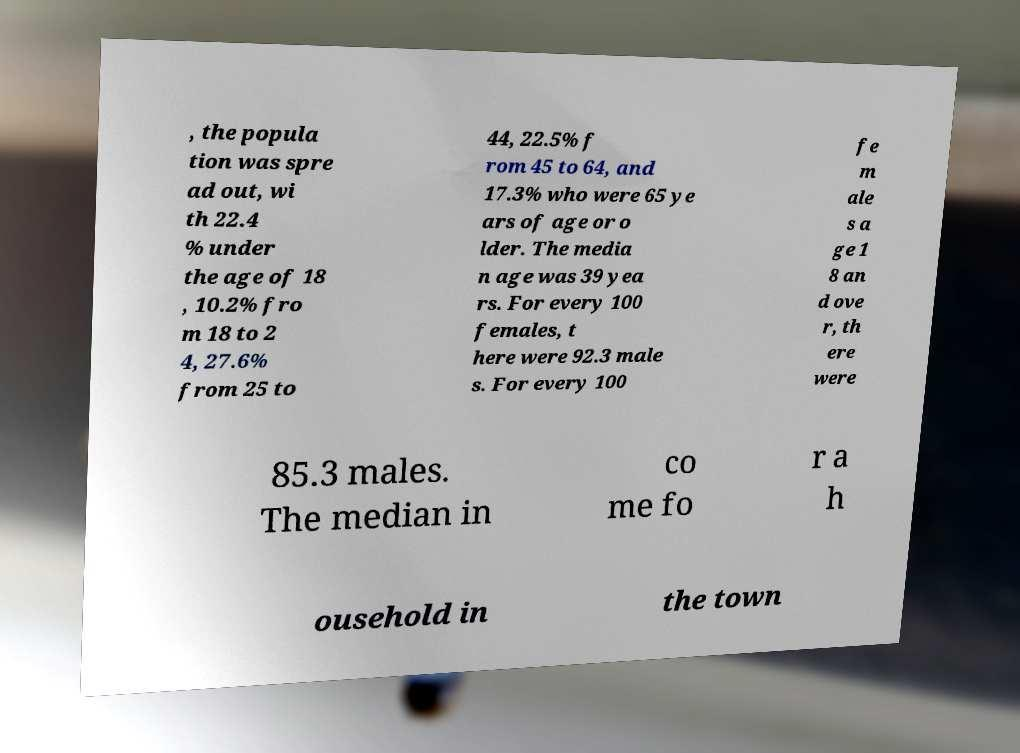Could you assist in decoding the text presented in this image and type it out clearly? , the popula tion was spre ad out, wi th 22.4 % under the age of 18 , 10.2% fro m 18 to 2 4, 27.6% from 25 to 44, 22.5% f rom 45 to 64, and 17.3% who were 65 ye ars of age or o lder. The media n age was 39 yea rs. For every 100 females, t here were 92.3 male s. For every 100 fe m ale s a ge 1 8 an d ove r, th ere were 85.3 males. The median in co me fo r a h ousehold in the town 